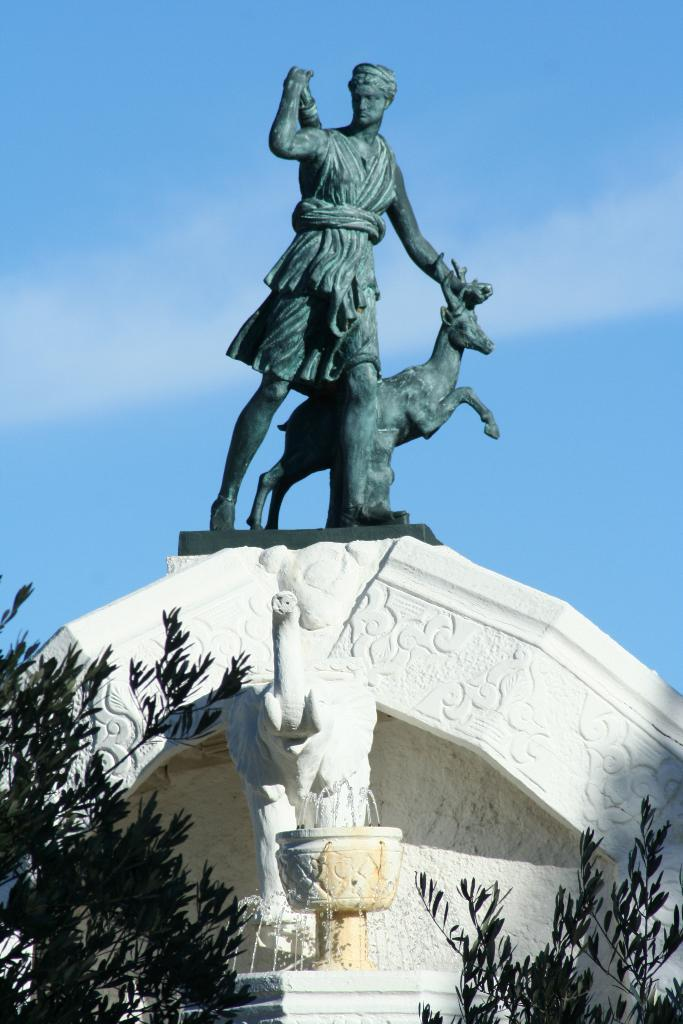What can be seen in the background of the image? The sky is visible in the background of the image. What is the statue of a person holding in the image? There is a statue of a person holding an animal in the image. What type of vegetation is present in the image? There are plants in the image. What type of water feature is in the image? There is a water fountain in the image. What other statue can be seen in the image? There is an elephant statue in the image. What type of plantation can be seen in the image? There is no plantation present in the image. What type of flesh is visible on the animal held by the statue? There is no flesh visible on the animal held by the statue, as it is a statue and not a real animal. 